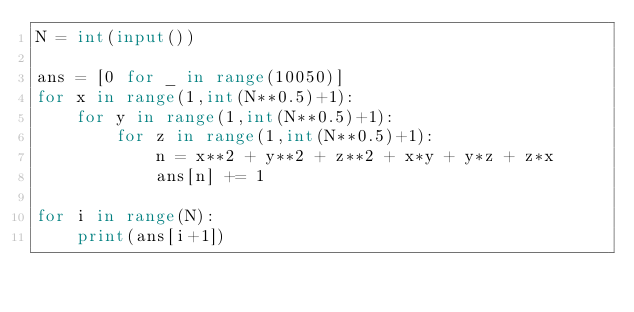<code> <loc_0><loc_0><loc_500><loc_500><_Python_>N = int(input())

ans = [0 for _ in range(10050)]
for x in range(1,int(N**0.5)+1):
    for y in range(1,int(N**0.5)+1):
        for z in range(1,int(N**0.5)+1):
            n = x**2 + y**2 + z**2 + x*y + y*z + z*x
            ans[n] += 1

for i in range(N):
    print(ans[i+1])</code> 